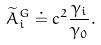Convert formula to latex. <formula><loc_0><loc_0><loc_500><loc_500>\widetilde { A } _ { i } ^ { G } \doteq c ^ { 2 } \frac { \gamma _ { i } } { \gamma _ { 0 } } .</formula> 